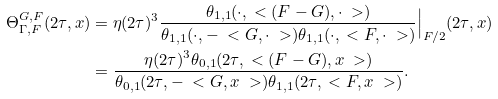Convert formula to latex. <formula><loc_0><loc_0><loc_500><loc_500>\Theta ^ { G , F } _ { \Gamma , F } ( 2 \tau , x ) & = \eta ( 2 \tau ) ^ { 3 } \frac { \theta _ { 1 , 1 } ( \cdot , \ < ( F - G ) , \cdot \ > ) } { \theta _ { 1 , 1 } ( \cdot , - \ < G , \cdot \ > ) \theta _ { 1 , 1 } ( \cdot , \ < F , \cdot \ > ) } \Big | _ { F / 2 } ( 2 \tau , x ) \\ & = \frac { \eta ( 2 \tau ) ^ { 3 } \theta _ { 0 , 1 } ( 2 \tau , \ < ( F - G ) , x \ > ) } { \theta _ { 0 , 1 } ( 2 \tau , - \ < G , x \ > ) \theta _ { 1 , 1 } ( 2 \tau , \ < F , x \ > ) } .</formula> 